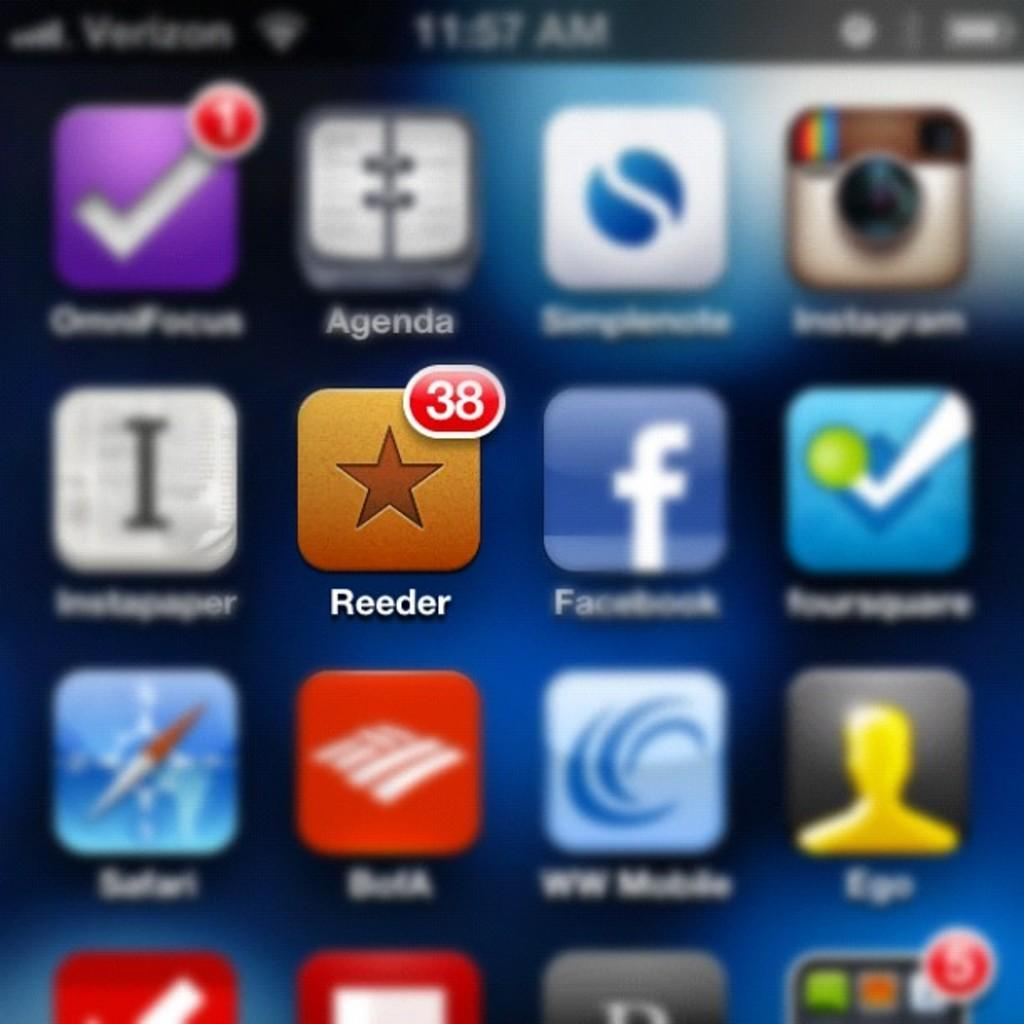<image>
Render a clear and concise summary of the photo. a Verizon cell phone displaying the app icons 